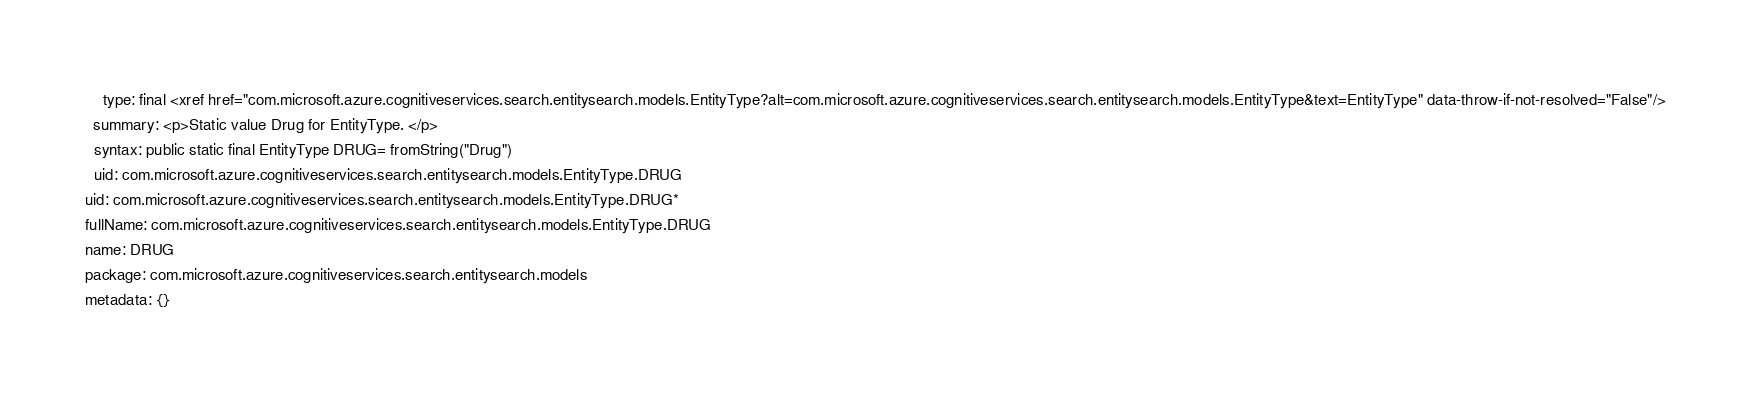<code> <loc_0><loc_0><loc_500><loc_500><_YAML_>    type: final <xref href="com.microsoft.azure.cognitiveservices.search.entitysearch.models.EntityType?alt=com.microsoft.azure.cognitiveservices.search.entitysearch.models.EntityType&text=EntityType" data-throw-if-not-resolved="False"/>
  summary: <p>Static value Drug for EntityType. </p>
  syntax: public static final EntityType DRUG= fromString("Drug")
  uid: com.microsoft.azure.cognitiveservices.search.entitysearch.models.EntityType.DRUG
uid: com.microsoft.azure.cognitiveservices.search.entitysearch.models.EntityType.DRUG*
fullName: com.microsoft.azure.cognitiveservices.search.entitysearch.models.EntityType.DRUG
name: DRUG
package: com.microsoft.azure.cognitiveservices.search.entitysearch.models
metadata: {}
</code> 